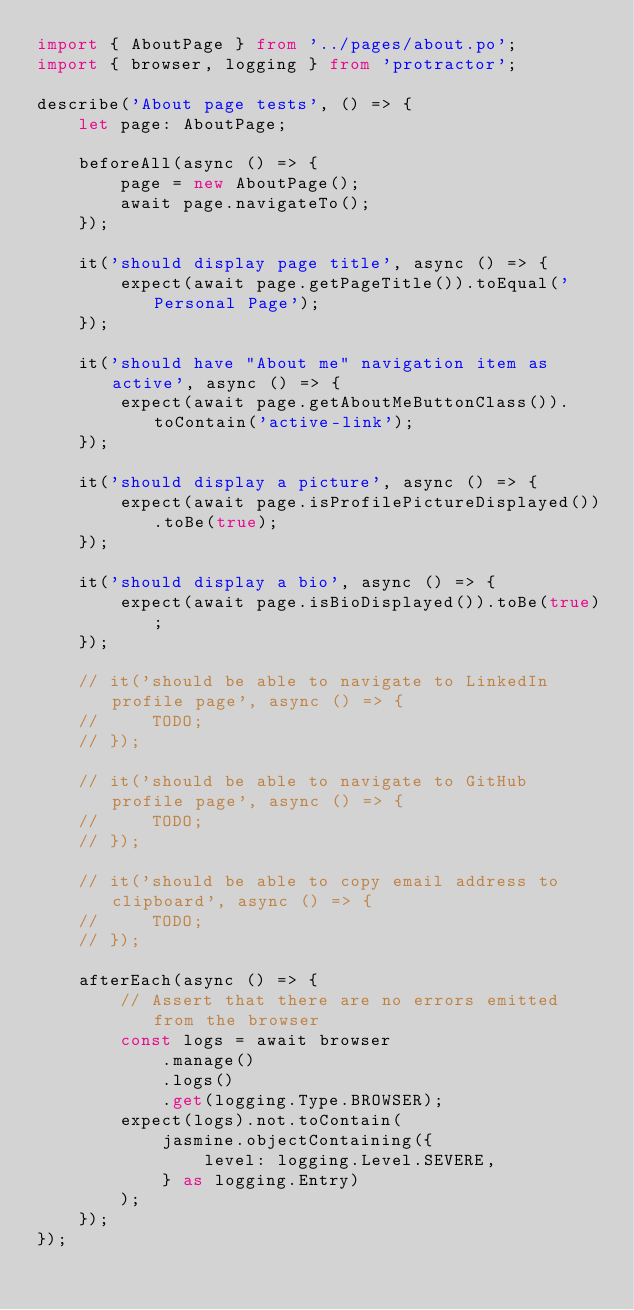Convert code to text. <code><loc_0><loc_0><loc_500><loc_500><_TypeScript_>import { AboutPage } from '../pages/about.po';
import { browser, logging } from 'protractor';

describe('About page tests', () => {
    let page: AboutPage;

    beforeAll(async () => {
        page = new AboutPage();
        await page.navigateTo();
    });

    it('should display page title', async () => {
        expect(await page.getPageTitle()).toEqual('Personal Page');
    });

    it('should have "About me" navigation item as active', async () => {
        expect(await page.getAboutMeButtonClass()).toContain('active-link');
    });

    it('should display a picture', async () => {
        expect(await page.isProfilePictureDisplayed()).toBe(true);
    });

    it('should display a bio', async () => {
        expect(await page.isBioDisplayed()).toBe(true);
    });

    // it('should be able to navigate to LinkedIn profile page', async () => {
    //     TODO;
    // });

    // it('should be able to navigate to GitHub profile page', async () => {
    //     TODO;
    // });

    // it('should be able to copy email address to clipboard', async () => {
    //     TODO;
    // });

    afterEach(async () => {
        // Assert that there are no errors emitted from the browser
        const logs = await browser
            .manage()
            .logs()
            .get(logging.Type.BROWSER);
        expect(logs).not.toContain(
            jasmine.objectContaining({
                level: logging.Level.SEVERE,
            } as logging.Entry)
        );
    });
});
</code> 